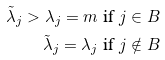Convert formula to latex. <formula><loc_0><loc_0><loc_500><loc_500>\tilde { \lambda } _ { j } > \lambda _ { j } = m & \text { if } j \in B \\ \tilde { \lambda } _ { j } = \lambda _ { j } & \text { if } j \notin B</formula> 